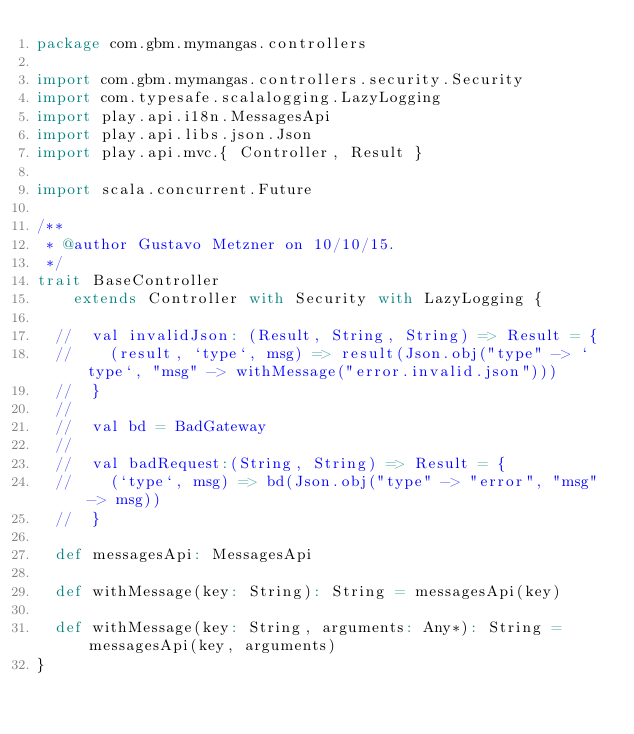Convert code to text. <code><loc_0><loc_0><loc_500><loc_500><_Scala_>package com.gbm.mymangas.controllers

import com.gbm.mymangas.controllers.security.Security
import com.typesafe.scalalogging.LazyLogging
import play.api.i18n.MessagesApi
import play.api.libs.json.Json
import play.api.mvc.{ Controller, Result }

import scala.concurrent.Future

/**
 * @author Gustavo Metzner on 10/10/15.
 */
trait BaseController
    extends Controller with Security with LazyLogging {

  //  val invalidJson: (Result, String, String) => Result = {
  //    (result, `type`, msg) => result(Json.obj("type" -> `type`, "msg" -> withMessage("error.invalid.json")))
  //  }
  //
  //  val bd = BadGateway
  //
  //  val badRequest:(String, String) => Result = {
  //    (`type`, msg) => bd(Json.obj("type" -> "error", "msg" -> msg))
  //  }

  def messagesApi: MessagesApi

  def withMessage(key: String): String = messagesApi(key)

  def withMessage(key: String, arguments: Any*): String = messagesApi(key, arguments)
}

</code> 